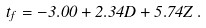<formula> <loc_0><loc_0><loc_500><loc_500>t _ { f } = - 3 . 0 0 + 2 . 3 4 D + 5 . 7 4 Z \, .</formula> 